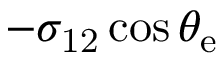Convert formula to latex. <formula><loc_0><loc_0><loc_500><loc_500>- \sigma _ { 1 2 } \cos \theta _ { e }</formula> 